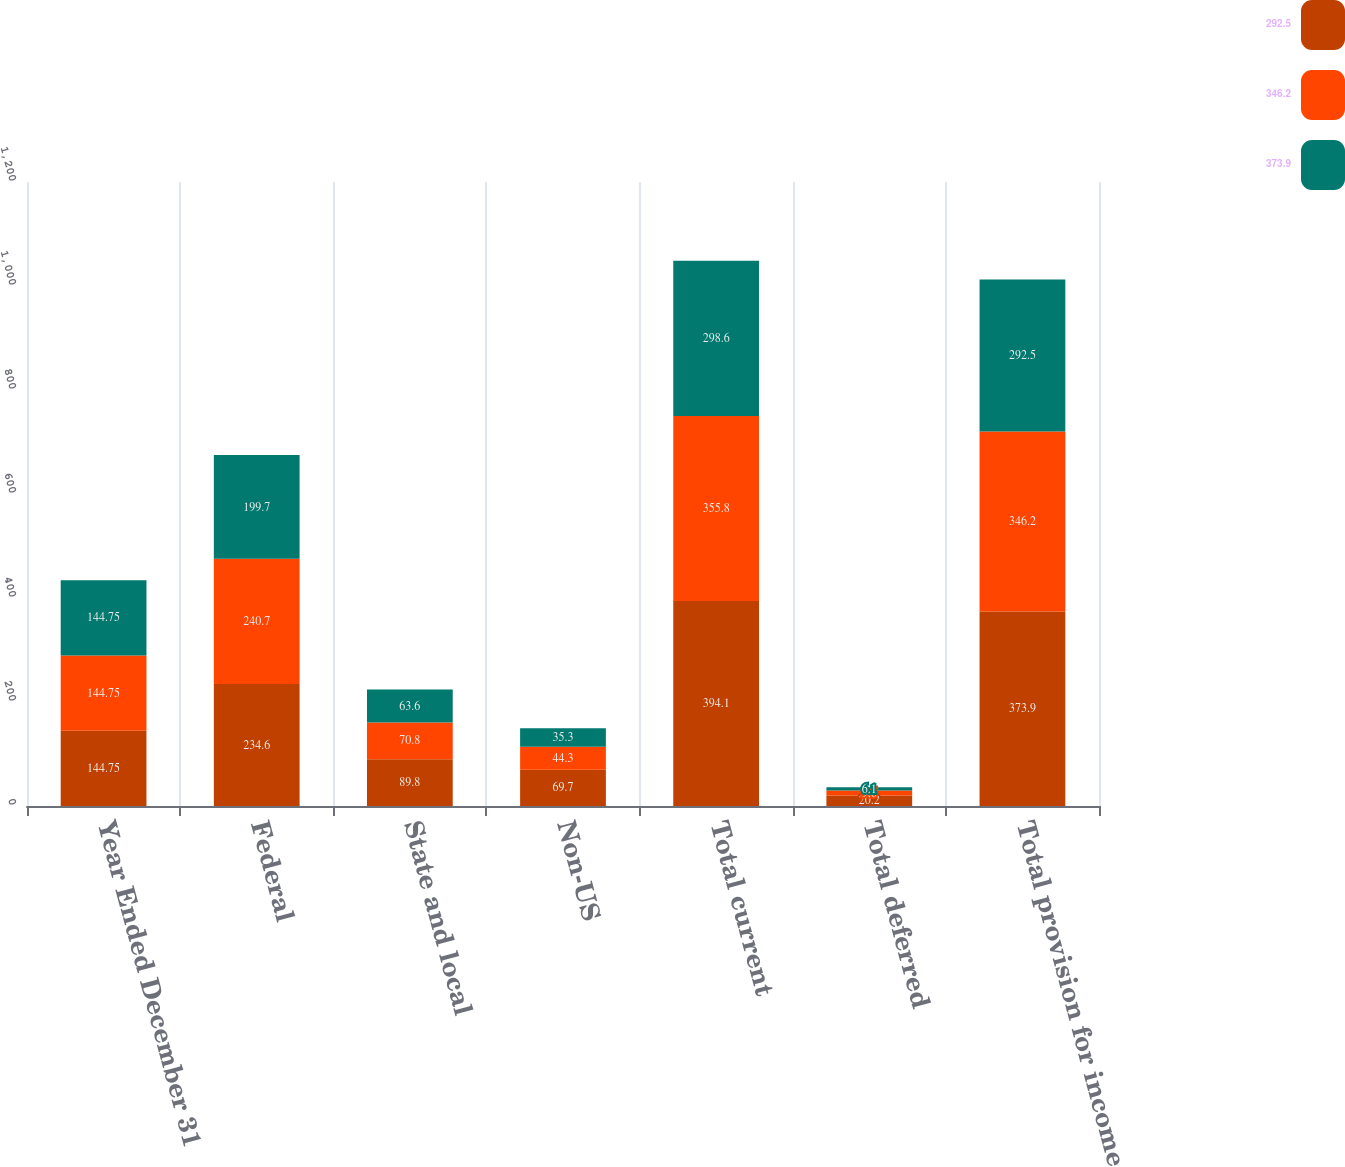Convert chart to OTSL. <chart><loc_0><loc_0><loc_500><loc_500><stacked_bar_chart><ecel><fcel>Year Ended December 31<fcel>Federal<fcel>State and local<fcel>Non-US<fcel>Total current<fcel>Total deferred<fcel>Total provision for income<nl><fcel>292.5<fcel>144.75<fcel>234.6<fcel>89.8<fcel>69.7<fcel>394.1<fcel>20.2<fcel>373.9<nl><fcel>346.2<fcel>144.75<fcel>240.7<fcel>70.8<fcel>44.3<fcel>355.8<fcel>9.6<fcel>346.2<nl><fcel>373.9<fcel>144.75<fcel>199.7<fcel>63.6<fcel>35.3<fcel>298.6<fcel>6.1<fcel>292.5<nl></chart> 